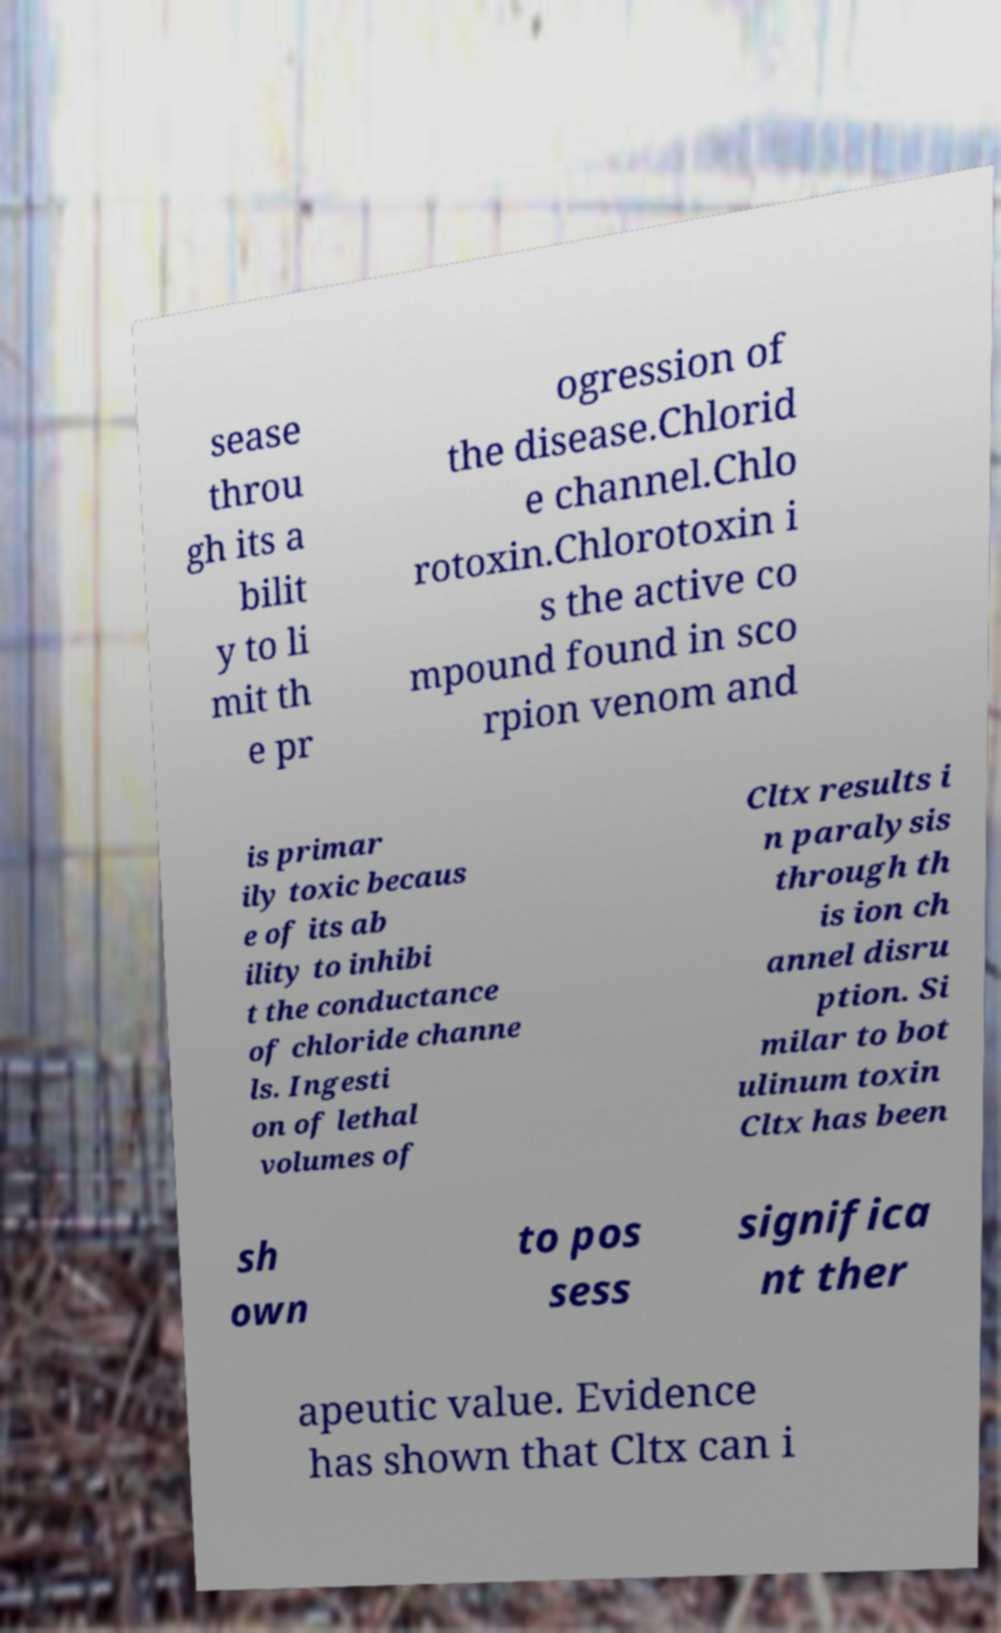Could you assist in decoding the text presented in this image and type it out clearly? sease throu gh its a bilit y to li mit th e pr ogression of the disease.Chlorid e channel.Chlo rotoxin.Chlorotoxin i s the active co mpound found in sco rpion venom and is primar ily toxic becaus e of its ab ility to inhibi t the conductance of chloride channe ls. Ingesti on of lethal volumes of Cltx results i n paralysis through th is ion ch annel disru ption. Si milar to bot ulinum toxin Cltx has been sh own to pos sess significa nt ther apeutic value. Evidence has shown that Cltx can i 